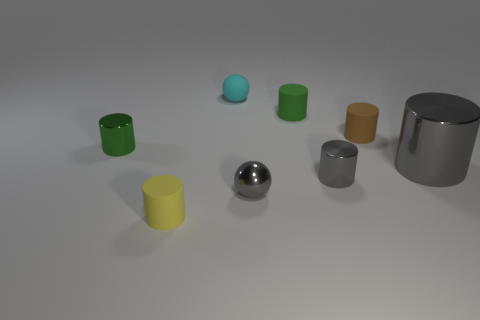Subtract 1 cylinders. How many cylinders are left? 5 Subtract all green cylinders. How many cylinders are left? 4 Subtract all small gray cylinders. How many cylinders are left? 5 Subtract all blue cylinders. Subtract all blue cubes. How many cylinders are left? 6 Add 1 green matte cylinders. How many objects exist? 9 Subtract all cylinders. How many objects are left? 2 Subtract 0 red balls. How many objects are left? 8 Subtract all big cylinders. Subtract all small rubber spheres. How many objects are left? 6 Add 2 tiny yellow cylinders. How many tiny yellow cylinders are left? 3 Add 2 large yellow things. How many large yellow things exist? 2 